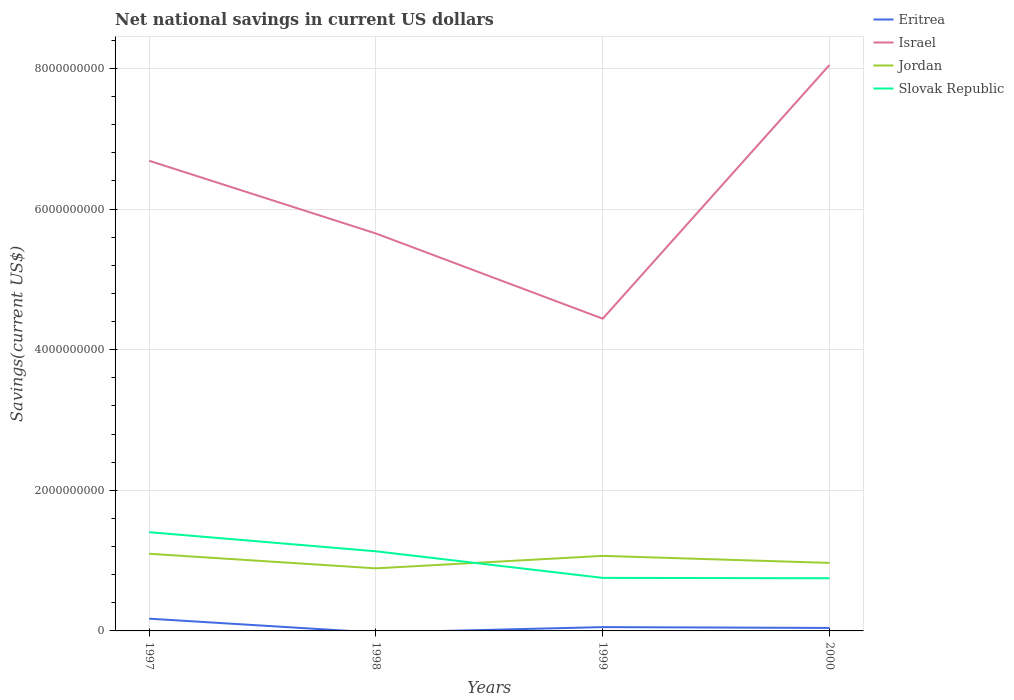Does the line corresponding to Jordan intersect with the line corresponding to Slovak Republic?
Your answer should be very brief. Yes. Is the number of lines equal to the number of legend labels?
Your answer should be compact. No. Across all years, what is the maximum net national savings in Israel?
Your answer should be compact. 4.44e+09. What is the total net national savings in Israel in the graph?
Offer a very short reply. -2.40e+09. What is the difference between the highest and the second highest net national savings in Slovak Republic?
Give a very brief answer. 6.55e+08. What is the difference between the highest and the lowest net national savings in Jordan?
Make the answer very short. 2. How many lines are there?
Provide a succinct answer. 4. Are the values on the major ticks of Y-axis written in scientific E-notation?
Ensure brevity in your answer.  No. Does the graph contain any zero values?
Ensure brevity in your answer.  Yes. Where does the legend appear in the graph?
Make the answer very short. Top right. How many legend labels are there?
Ensure brevity in your answer.  4. What is the title of the graph?
Offer a terse response. Net national savings in current US dollars. Does "Namibia" appear as one of the legend labels in the graph?
Offer a terse response. No. What is the label or title of the Y-axis?
Make the answer very short. Savings(current US$). What is the Savings(current US$) of Eritrea in 1997?
Make the answer very short. 1.74e+08. What is the Savings(current US$) in Israel in 1997?
Keep it short and to the point. 6.69e+09. What is the Savings(current US$) of Jordan in 1997?
Give a very brief answer. 1.10e+09. What is the Savings(current US$) of Slovak Republic in 1997?
Keep it short and to the point. 1.40e+09. What is the Savings(current US$) of Eritrea in 1998?
Give a very brief answer. 0. What is the Savings(current US$) of Israel in 1998?
Your response must be concise. 5.65e+09. What is the Savings(current US$) of Jordan in 1998?
Your answer should be compact. 8.90e+08. What is the Savings(current US$) in Slovak Republic in 1998?
Your answer should be compact. 1.13e+09. What is the Savings(current US$) of Eritrea in 1999?
Your answer should be very brief. 5.43e+07. What is the Savings(current US$) of Israel in 1999?
Keep it short and to the point. 4.44e+09. What is the Savings(current US$) in Jordan in 1999?
Provide a succinct answer. 1.07e+09. What is the Savings(current US$) of Slovak Republic in 1999?
Your response must be concise. 7.54e+08. What is the Savings(current US$) in Eritrea in 2000?
Make the answer very short. 4.25e+07. What is the Savings(current US$) in Israel in 2000?
Provide a short and direct response. 8.05e+09. What is the Savings(current US$) of Jordan in 2000?
Provide a short and direct response. 9.67e+08. What is the Savings(current US$) in Slovak Republic in 2000?
Offer a terse response. 7.49e+08. Across all years, what is the maximum Savings(current US$) in Eritrea?
Offer a terse response. 1.74e+08. Across all years, what is the maximum Savings(current US$) of Israel?
Your answer should be very brief. 8.05e+09. Across all years, what is the maximum Savings(current US$) in Jordan?
Keep it short and to the point. 1.10e+09. Across all years, what is the maximum Savings(current US$) of Slovak Republic?
Ensure brevity in your answer.  1.40e+09. Across all years, what is the minimum Savings(current US$) of Eritrea?
Keep it short and to the point. 0. Across all years, what is the minimum Savings(current US$) of Israel?
Your response must be concise. 4.44e+09. Across all years, what is the minimum Savings(current US$) in Jordan?
Your response must be concise. 8.90e+08. Across all years, what is the minimum Savings(current US$) in Slovak Republic?
Offer a very short reply. 7.49e+08. What is the total Savings(current US$) of Eritrea in the graph?
Offer a terse response. 2.71e+08. What is the total Savings(current US$) of Israel in the graph?
Your answer should be very brief. 2.48e+1. What is the total Savings(current US$) of Jordan in the graph?
Keep it short and to the point. 4.02e+09. What is the total Savings(current US$) of Slovak Republic in the graph?
Offer a terse response. 4.04e+09. What is the difference between the Savings(current US$) of Israel in 1997 and that in 1998?
Keep it short and to the point. 1.03e+09. What is the difference between the Savings(current US$) in Jordan in 1997 and that in 1998?
Offer a very short reply. 2.07e+08. What is the difference between the Savings(current US$) of Slovak Republic in 1997 and that in 1998?
Make the answer very short. 2.72e+08. What is the difference between the Savings(current US$) in Eritrea in 1997 and that in 1999?
Give a very brief answer. 1.20e+08. What is the difference between the Savings(current US$) of Israel in 1997 and that in 1999?
Provide a succinct answer. 2.25e+09. What is the difference between the Savings(current US$) in Jordan in 1997 and that in 1999?
Your response must be concise. 3.00e+07. What is the difference between the Savings(current US$) in Slovak Republic in 1997 and that in 1999?
Your response must be concise. 6.50e+08. What is the difference between the Savings(current US$) in Eritrea in 1997 and that in 2000?
Ensure brevity in your answer.  1.32e+08. What is the difference between the Savings(current US$) of Israel in 1997 and that in 2000?
Your response must be concise. -1.36e+09. What is the difference between the Savings(current US$) in Jordan in 1997 and that in 2000?
Your answer should be very brief. 1.30e+08. What is the difference between the Savings(current US$) of Slovak Republic in 1997 and that in 2000?
Provide a succinct answer. 6.55e+08. What is the difference between the Savings(current US$) in Israel in 1998 and that in 1999?
Your response must be concise. 1.21e+09. What is the difference between the Savings(current US$) of Jordan in 1998 and that in 1999?
Make the answer very short. -1.77e+08. What is the difference between the Savings(current US$) of Slovak Republic in 1998 and that in 1999?
Offer a terse response. 3.78e+08. What is the difference between the Savings(current US$) in Israel in 1998 and that in 2000?
Provide a succinct answer. -2.40e+09. What is the difference between the Savings(current US$) in Jordan in 1998 and that in 2000?
Offer a terse response. -7.72e+07. What is the difference between the Savings(current US$) in Slovak Republic in 1998 and that in 2000?
Keep it short and to the point. 3.84e+08. What is the difference between the Savings(current US$) of Eritrea in 1999 and that in 2000?
Provide a succinct answer. 1.18e+07. What is the difference between the Savings(current US$) of Israel in 1999 and that in 2000?
Provide a short and direct response. -3.61e+09. What is the difference between the Savings(current US$) in Jordan in 1999 and that in 2000?
Ensure brevity in your answer.  1.00e+08. What is the difference between the Savings(current US$) of Slovak Republic in 1999 and that in 2000?
Ensure brevity in your answer.  5.50e+06. What is the difference between the Savings(current US$) of Eritrea in 1997 and the Savings(current US$) of Israel in 1998?
Your answer should be very brief. -5.48e+09. What is the difference between the Savings(current US$) in Eritrea in 1997 and the Savings(current US$) in Jordan in 1998?
Your response must be concise. -7.16e+08. What is the difference between the Savings(current US$) in Eritrea in 1997 and the Savings(current US$) in Slovak Republic in 1998?
Give a very brief answer. -9.58e+08. What is the difference between the Savings(current US$) of Israel in 1997 and the Savings(current US$) of Jordan in 1998?
Provide a short and direct response. 5.80e+09. What is the difference between the Savings(current US$) of Israel in 1997 and the Savings(current US$) of Slovak Republic in 1998?
Give a very brief answer. 5.55e+09. What is the difference between the Savings(current US$) of Jordan in 1997 and the Savings(current US$) of Slovak Republic in 1998?
Keep it short and to the point. -3.50e+07. What is the difference between the Savings(current US$) of Eritrea in 1997 and the Savings(current US$) of Israel in 1999?
Offer a terse response. -4.27e+09. What is the difference between the Savings(current US$) in Eritrea in 1997 and the Savings(current US$) in Jordan in 1999?
Make the answer very short. -8.93e+08. What is the difference between the Savings(current US$) of Eritrea in 1997 and the Savings(current US$) of Slovak Republic in 1999?
Your response must be concise. -5.80e+08. What is the difference between the Savings(current US$) of Israel in 1997 and the Savings(current US$) of Jordan in 1999?
Offer a terse response. 5.62e+09. What is the difference between the Savings(current US$) in Israel in 1997 and the Savings(current US$) in Slovak Republic in 1999?
Provide a succinct answer. 5.93e+09. What is the difference between the Savings(current US$) in Jordan in 1997 and the Savings(current US$) in Slovak Republic in 1999?
Your answer should be compact. 3.43e+08. What is the difference between the Savings(current US$) of Eritrea in 1997 and the Savings(current US$) of Israel in 2000?
Your answer should be very brief. -7.88e+09. What is the difference between the Savings(current US$) in Eritrea in 1997 and the Savings(current US$) in Jordan in 2000?
Your answer should be very brief. -7.93e+08. What is the difference between the Savings(current US$) in Eritrea in 1997 and the Savings(current US$) in Slovak Republic in 2000?
Your response must be concise. -5.75e+08. What is the difference between the Savings(current US$) of Israel in 1997 and the Savings(current US$) of Jordan in 2000?
Ensure brevity in your answer.  5.72e+09. What is the difference between the Savings(current US$) of Israel in 1997 and the Savings(current US$) of Slovak Republic in 2000?
Give a very brief answer. 5.94e+09. What is the difference between the Savings(current US$) in Jordan in 1997 and the Savings(current US$) in Slovak Republic in 2000?
Keep it short and to the point. 3.49e+08. What is the difference between the Savings(current US$) in Israel in 1998 and the Savings(current US$) in Jordan in 1999?
Provide a short and direct response. 4.59e+09. What is the difference between the Savings(current US$) in Israel in 1998 and the Savings(current US$) in Slovak Republic in 1999?
Provide a succinct answer. 4.90e+09. What is the difference between the Savings(current US$) of Jordan in 1998 and the Savings(current US$) of Slovak Republic in 1999?
Provide a succinct answer. 1.36e+08. What is the difference between the Savings(current US$) in Israel in 1998 and the Savings(current US$) in Jordan in 2000?
Ensure brevity in your answer.  4.69e+09. What is the difference between the Savings(current US$) of Israel in 1998 and the Savings(current US$) of Slovak Republic in 2000?
Keep it short and to the point. 4.90e+09. What is the difference between the Savings(current US$) in Jordan in 1998 and the Savings(current US$) in Slovak Republic in 2000?
Make the answer very short. 1.41e+08. What is the difference between the Savings(current US$) in Eritrea in 1999 and the Savings(current US$) in Israel in 2000?
Ensure brevity in your answer.  -8.00e+09. What is the difference between the Savings(current US$) of Eritrea in 1999 and the Savings(current US$) of Jordan in 2000?
Offer a very short reply. -9.13e+08. What is the difference between the Savings(current US$) in Eritrea in 1999 and the Savings(current US$) in Slovak Republic in 2000?
Your response must be concise. -6.95e+08. What is the difference between the Savings(current US$) in Israel in 1999 and the Savings(current US$) in Jordan in 2000?
Offer a very short reply. 3.47e+09. What is the difference between the Savings(current US$) of Israel in 1999 and the Savings(current US$) of Slovak Republic in 2000?
Give a very brief answer. 3.69e+09. What is the difference between the Savings(current US$) of Jordan in 1999 and the Savings(current US$) of Slovak Republic in 2000?
Give a very brief answer. 3.18e+08. What is the average Savings(current US$) in Eritrea per year?
Keep it short and to the point. 6.77e+07. What is the average Savings(current US$) of Israel per year?
Ensure brevity in your answer.  6.21e+09. What is the average Savings(current US$) in Jordan per year?
Give a very brief answer. 1.01e+09. What is the average Savings(current US$) in Slovak Republic per year?
Your response must be concise. 1.01e+09. In the year 1997, what is the difference between the Savings(current US$) of Eritrea and Savings(current US$) of Israel?
Ensure brevity in your answer.  -6.51e+09. In the year 1997, what is the difference between the Savings(current US$) of Eritrea and Savings(current US$) of Jordan?
Keep it short and to the point. -9.23e+08. In the year 1997, what is the difference between the Savings(current US$) of Eritrea and Savings(current US$) of Slovak Republic?
Ensure brevity in your answer.  -1.23e+09. In the year 1997, what is the difference between the Savings(current US$) of Israel and Savings(current US$) of Jordan?
Give a very brief answer. 5.59e+09. In the year 1997, what is the difference between the Savings(current US$) of Israel and Savings(current US$) of Slovak Republic?
Give a very brief answer. 5.28e+09. In the year 1997, what is the difference between the Savings(current US$) in Jordan and Savings(current US$) in Slovak Republic?
Your answer should be compact. -3.07e+08. In the year 1998, what is the difference between the Savings(current US$) in Israel and Savings(current US$) in Jordan?
Make the answer very short. 4.76e+09. In the year 1998, what is the difference between the Savings(current US$) in Israel and Savings(current US$) in Slovak Republic?
Offer a terse response. 4.52e+09. In the year 1998, what is the difference between the Savings(current US$) in Jordan and Savings(current US$) in Slovak Republic?
Your answer should be compact. -2.42e+08. In the year 1999, what is the difference between the Savings(current US$) in Eritrea and Savings(current US$) in Israel?
Give a very brief answer. -4.39e+09. In the year 1999, what is the difference between the Savings(current US$) in Eritrea and Savings(current US$) in Jordan?
Ensure brevity in your answer.  -1.01e+09. In the year 1999, what is the difference between the Savings(current US$) in Eritrea and Savings(current US$) in Slovak Republic?
Keep it short and to the point. -7.00e+08. In the year 1999, what is the difference between the Savings(current US$) in Israel and Savings(current US$) in Jordan?
Make the answer very short. 3.37e+09. In the year 1999, what is the difference between the Savings(current US$) of Israel and Savings(current US$) of Slovak Republic?
Your answer should be very brief. 3.69e+09. In the year 1999, what is the difference between the Savings(current US$) of Jordan and Savings(current US$) of Slovak Republic?
Provide a succinct answer. 3.13e+08. In the year 2000, what is the difference between the Savings(current US$) of Eritrea and Savings(current US$) of Israel?
Provide a succinct answer. -8.01e+09. In the year 2000, what is the difference between the Savings(current US$) of Eritrea and Savings(current US$) of Jordan?
Make the answer very short. -9.25e+08. In the year 2000, what is the difference between the Savings(current US$) of Eritrea and Savings(current US$) of Slovak Republic?
Provide a succinct answer. -7.06e+08. In the year 2000, what is the difference between the Savings(current US$) of Israel and Savings(current US$) of Jordan?
Provide a short and direct response. 7.08e+09. In the year 2000, what is the difference between the Savings(current US$) of Israel and Savings(current US$) of Slovak Republic?
Give a very brief answer. 7.30e+09. In the year 2000, what is the difference between the Savings(current US$) in Jordan and Savings(current US$) in Slovak Republic?
Make the answer very short. 2.18e+08. What is the ratio of the Savings(current US$) in Israel in 1997 to that in 1998?
Your answer should be compact. 1.18. What is the ratio of the Savings(current US$) of Jordan in 1997 to that in 1998?
Keep it short and to the point. 1.23. What is the ratio of the Savings(current US$) in Slovak Republic in 1997 to that in 1998?
Make the answer very short. 1.24. What is the ratio of the Savings(current US$) of Eritrea in 1997 to that in 1999?
Make the answer very short. 3.21. What is the ratio of the Savings(current US$) in Israel in 1997 to that in 1999?
Make the answer very short. 1.51. What is the ratio of the Savings(current US$) of Jordan in 1997 to that in 1999?
Your answer should be very brief. 1.03. What is the ratio of the Savings(current US$) in Slovak Republic in 1997 to that in 1999?
Your answer should be compact. 1.86. What is the ratio of the Savings(current US$) of Eritrea in 1997 to that in 2000?
Offer a terse response. 4.1. What is the ratio of the Savings(current US$) of Israel in 1997 to that in 2000?
Give a very brief answer. 0.83. What is the ratio of the Savings(current US$) in Jordan in 1997 to that in 2000?
Offer a very short reply. 1.13. What is the ratio of the Savings(current US$) in Slovak Republic in 1997 to that in 2000?
Ensure brevity in your answer.  1.88. What is the ratio of the Savings(current US$) of Israel in 1998 to that in 1999?
Give a very brief answer. 1.27. What is the ratio of the Savings(current US$) in Jordan in 1998 to that in 1999?
Offer a very short reply. 0.83. What is the ratio of the Savings(current US$) of Slovak Republic in 1998 to that in 1999?
Offer a terse response. 1.5. What is the ratio of the Savings(current US$) in Israel in 1998 to that in 2000?
Offer a very short reply. 0.7. What is the ratio of the Savings(current US$) in Jordan in 1998 to that in 2000?
Offer a very short reply. 0.92. What is the ratio of the Savings(current US$) in Slovak Republic in 1998 to that in 2000?
Provide a succinct answer. 1.51. What is the ratio of the Savings(current US$) in Eritrea in 1999 to that in 2000?
Offer a very short reply. 1.28. What is the ratio of the Savings(current US$) of Israel in 1999 to that in 2000?
Provide a short and direct response. 0.55. What is the ratio of the Savings(current US$) of Jordan in 1999 to that in 2000?
Your answer should be compact. 1.1. What is the ratio of the Savings(current US$) in Slovak Republic in 1999 to that in 2000?
Make the answer very short. 1.01. What is the difference between the highest and the second highest Savings(current US$) of Eritrea?
Your answer should be very brief. 1.20e+08. What is the difference between the highest and the second highest Savings(current US$) of Israel?
Ensure brevity in your answer.  1.36e+09. What is the difference between the highest and the second highest Savings(current US$) in Jordan?
Your answer should be very brief. 3.00e+07. What is the difference between the highest and the second highest Savings(current US$) of Slovak Republic?
Ensure brevity in your answer.  2.72e+08. What is the difference between the highest and the lowest Savings(current US$) in Eritrea?
Provide a short and direct response. 1.74e+08. What is the difference between the highest and the lowest Savings(current US$) of Israel?
Offer a terse response. 3.61e+09. What is the difference between the highest and the lowest Savings(current US$) of Jordan?
Provide a short and direct response. 2.07e+08. What is the difference between the highest and the lowest Savings(current US$) of Slovak Republic?
Provide a succinct answer. 6.55e+08. 